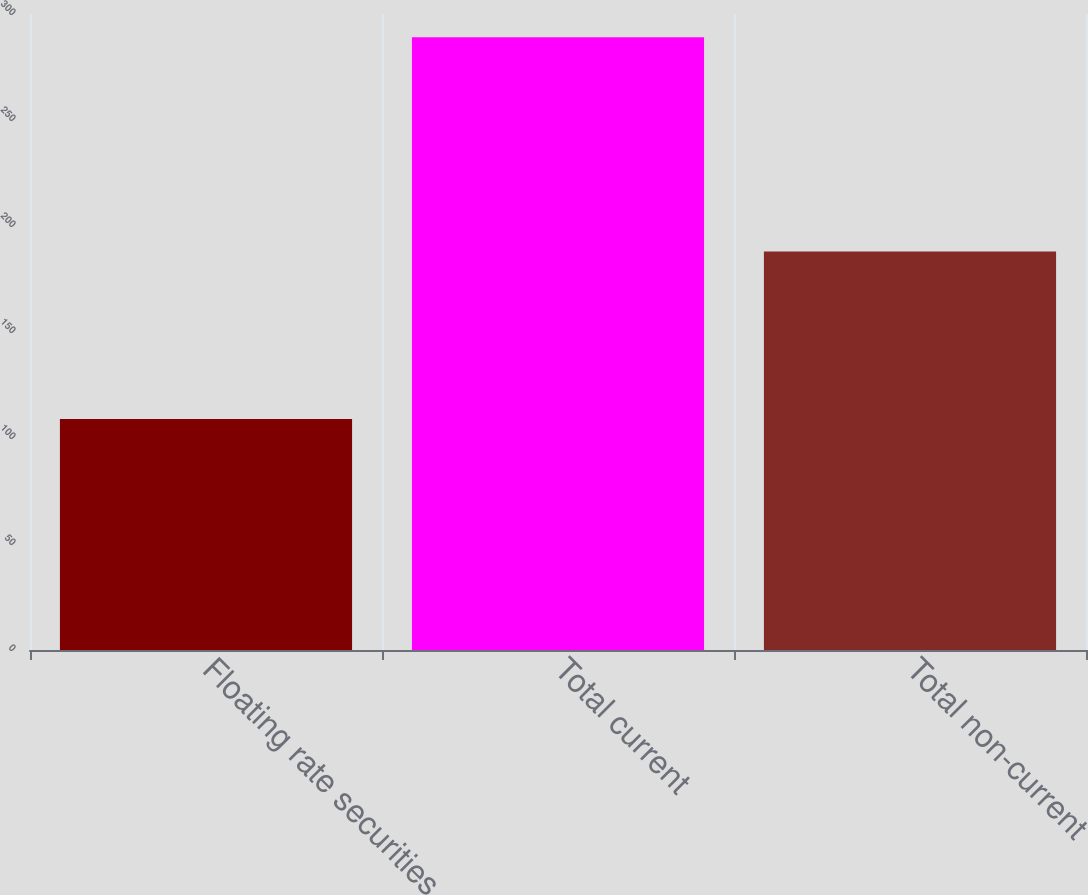Convert chart. <chart><loc_0><loc_0><loc_500><loc_500><bar_chart><fcel>Floating rate securities<fcel>Total current<fcel>Total non-current<nl><fcel>109<fcel>289<fcel>188<nl></chart> 